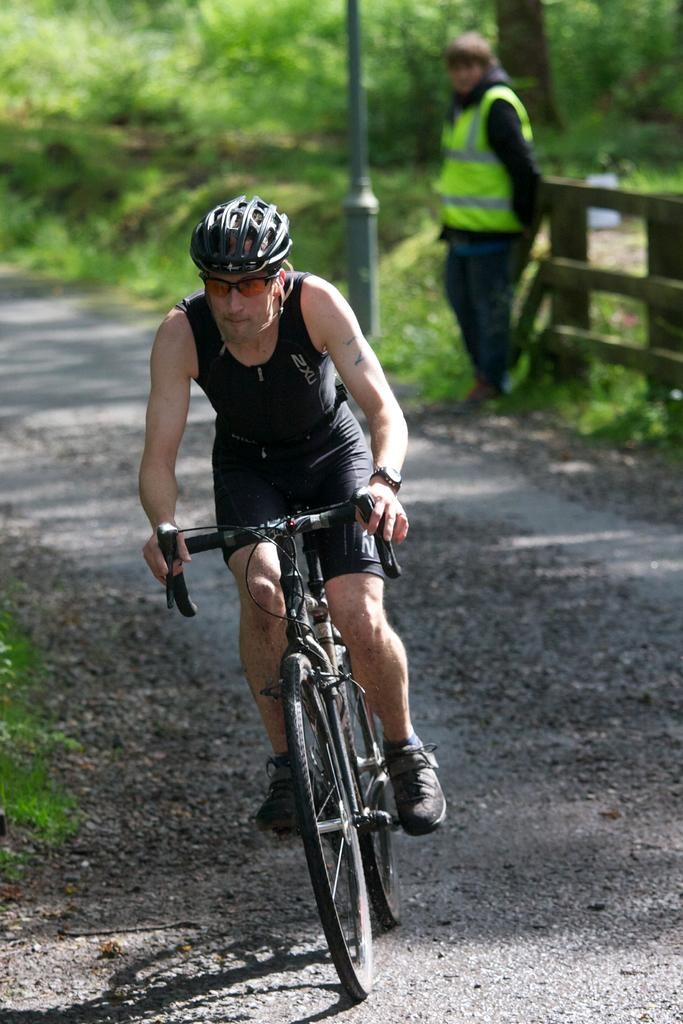What is the man in the image doing? The man is sitting on a bicycle. What safety precaution is the man taking in the image? The man is wearing a helmet. Can you describe the second person in the image? The second person is standing at the back of the bicycle. How many legs does the cherry have in the image? There is no cherry present in the image. Who is the owner of the bicycle in the image? The image does not provide information about the ownership of the bicycle. 